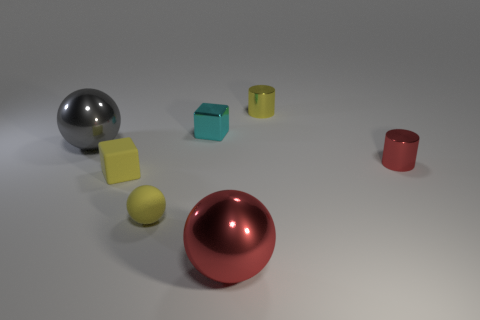Add 1 cyan metallic things. How many objects exist? 8 Subtract all small spheres. How many spheres are left? 2 Subtract all cyan cubes. How many cubes are left? 1 Subtract all blocks. How many objects are left? 5 Subtract all small green rubber spheres. Subtract all big metal things. How many objects are left? 5 Add 5 big red things. How many big red things are left? 6 Add 3 yellow balls. How many yellow balls exist? 4 Subtract 0 blue cylinders. How many objects are left? 7 Subtract 1 spheres. How many spheres are left? 2 Subtract all brown blocks. Subtract all green spheres. How many blocks are left? 2 